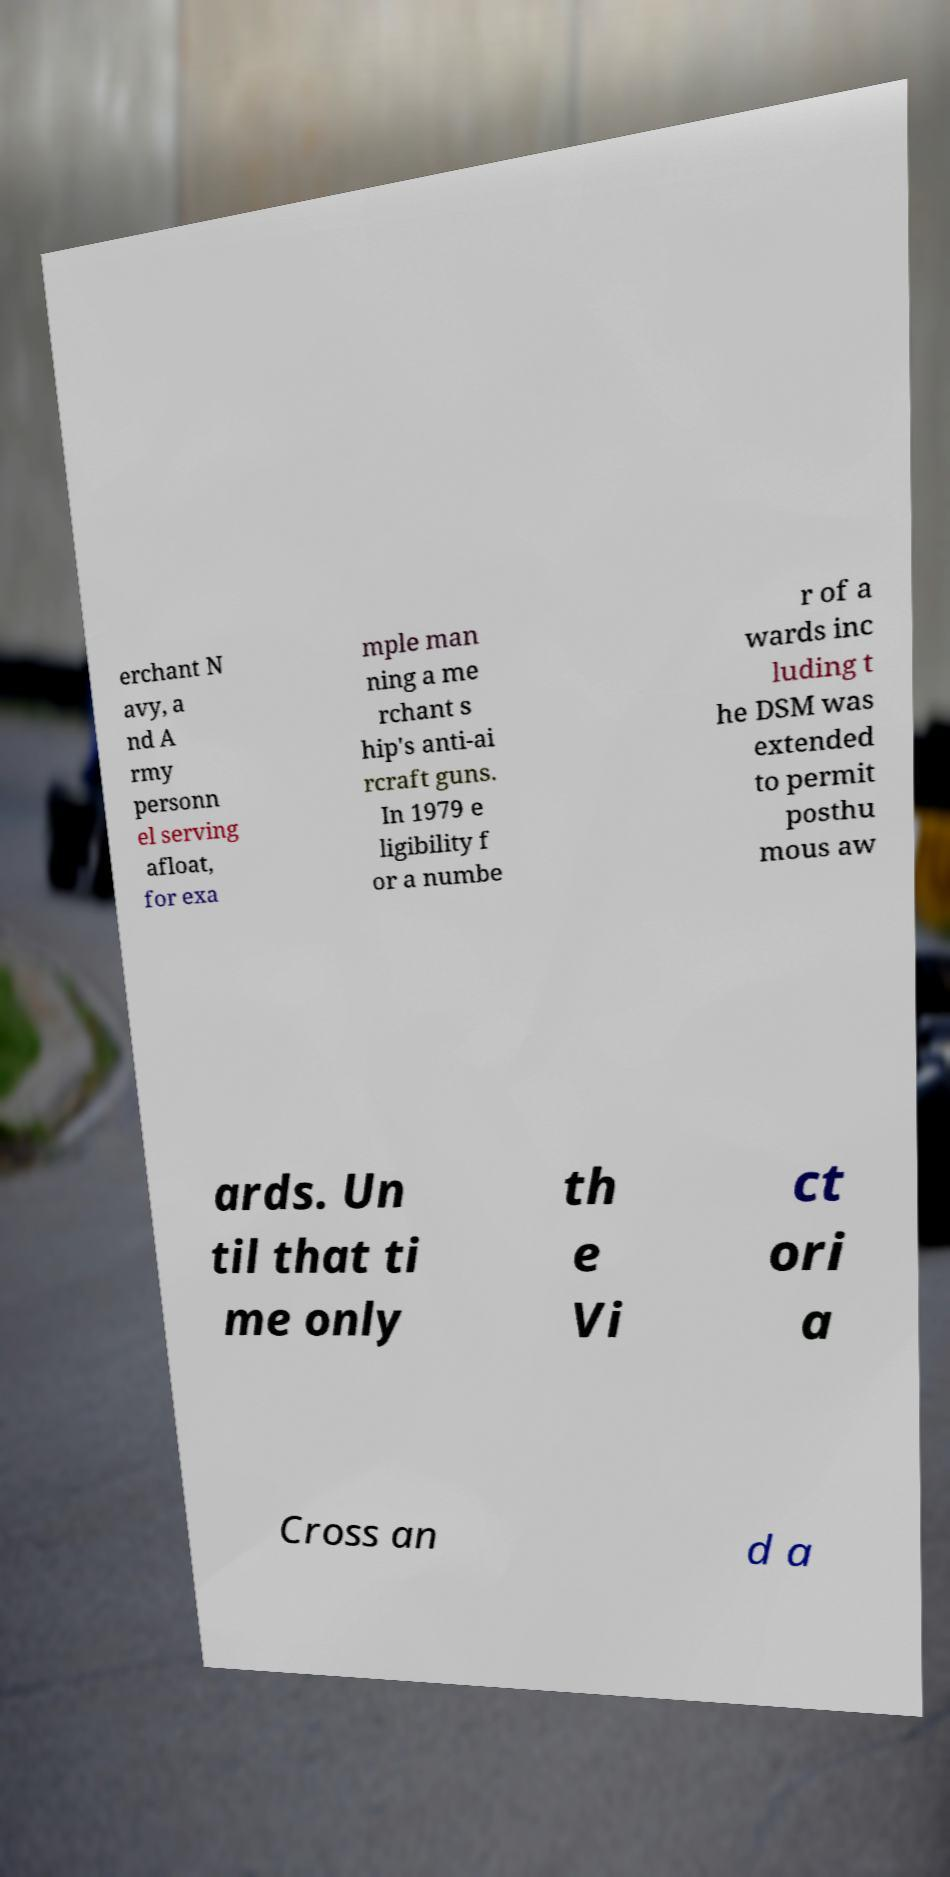For documentation purposes, I need the text within this image transcribed. Could you provide that? erchant N avy, a nd A rmy personn el serving afloat, for exa mple man ning a me rchant s hip's anti-ai rcraft guns. In 1979 e ligibility f or a numbe r of a wards inc luding t he DSM was extended to permit posthu mous aw ards. Un til that ti me only th e Vi ct ori a Cross an d a 